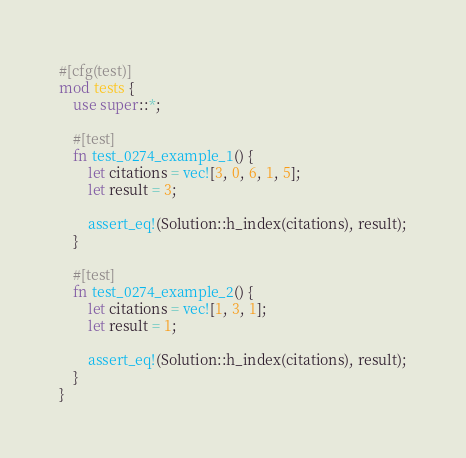Convert code to text. <code><loc_0><loc_0><loc_500><loc_500><_Rust_>#[cfg(test)]
mod tests {
    use super::*;

    #[test]
    fn test_0274_example_1() {
        let citations = vec![3, 0, 6, 1, 5];
        let result = 3;

        assert_eq!(Solution::h_index(citations), result);
    }

    #[test]
    fn test_0274_example_2() {
        let citations = vec![1, 3, 1];
        let result = 1;

        assert_eq!(Solution::h_index(citations), result);
    }
}
</code> 